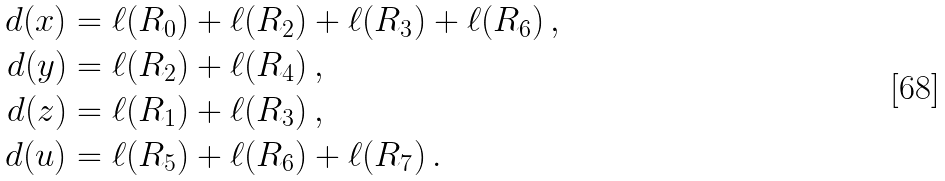Convert formula to latex. <formula><loc_0><loc_0><loc_500><loc_500>d ( x ) & = \ell ( R _ { 0 } ) + \ell ( R _ { 2 } ) + \ell ( R _ { 3 } ) + \ell ( R _ { 6 } ) \, , \\ d ( y ) & = \ell ( R _ { 2 } ) + \ell ( R _ { 4 } ) \, , \\ d ( z ) & = \ell ( R _ { 1 } ) + \ell ( R _ { 3 } ) \, , \\ d ( u ) & = \ell ( R _ { 5 } ) + \ell ( R _ { 6 } ) + \ell ( R _ { 7 } ) \, .</formula> 